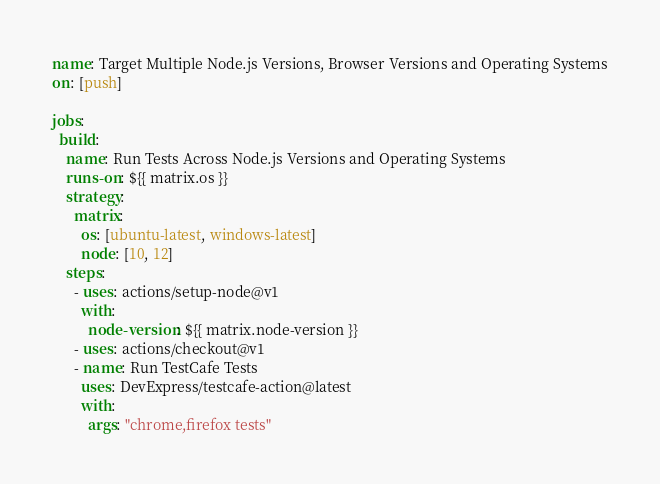<code> <loc_0><loc_0><loc_500><loc_500><_YAML_>name: Target Multiple Node.js Versions, Browser Versions and Operating Systems
on: [push]

jobs:
  build:
    name: Run Tests Across Node.js Versions and Operating Systems
    runs-on: ${{ matrix.os }}
    strategy:
      matrix:
        os: [ubuntu-latest, windows-latest]
        node: [10, 12]
    steps:
      - uses: actions/setup-node@v1
        with:
          node-version: ${{ matrix.node-version }}
      - uses: actions/checkout@v1
      - name: Run TestCafe Tests
        uses: DevExpress/testcafe-action@latest
        with:
          args: "chrome,firefox tests"
</code> 